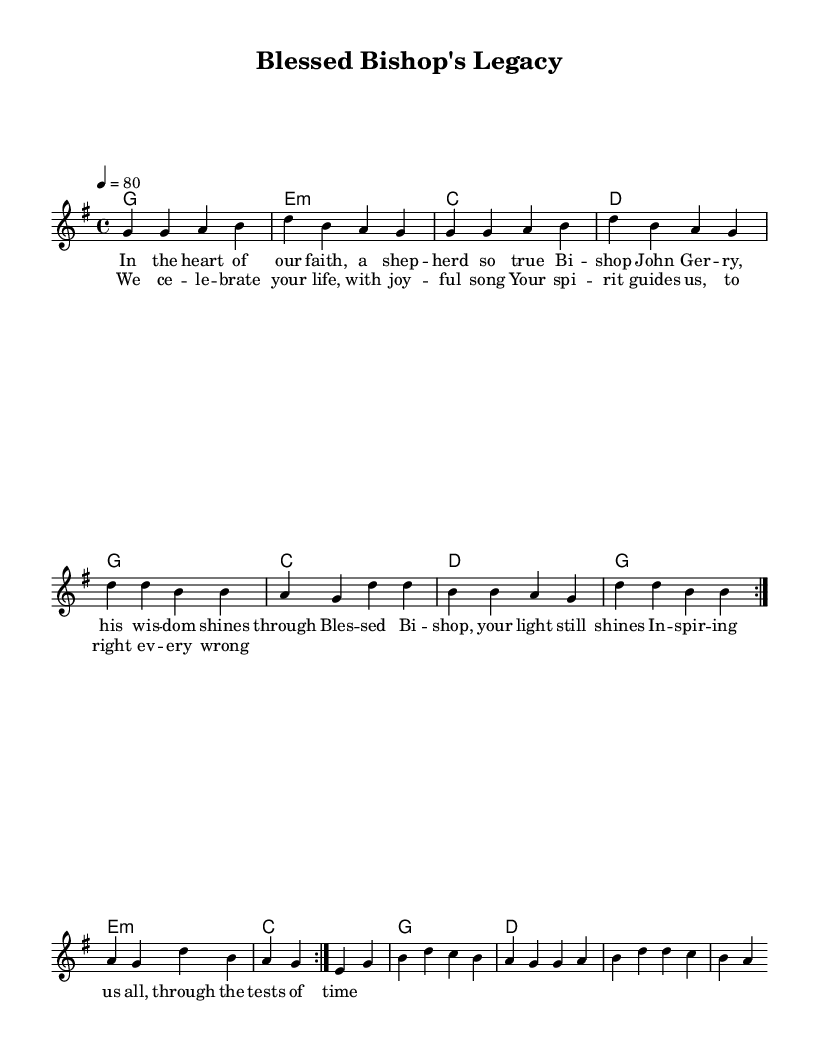What is the title of this piece? The title is found in the header section of the sheet music, clearly stating "Blessed Bishop's Legacy."
Answer: Blessed Bishop's Legacy What is the key signature of this music? The key signature is indicated at the beginning of the score, and in this case, it is G major, which has one sharp.
Answer: G major What is the time signature of this music? The time signature appears next to the key signature at the beginning of the score, showing a 4/4 pattern.
Answer: 4/4 What is the tempo marking of this piece? The tempo is provided in the global section as "4 = 80," which indicates the metronome mark and speed of the piece.
Answer: 80 How many times is the melody repeated in the first section? By looking at the repeat signs present in the melody section, it shows that the melody is repeated twice in the first section.
Answer: 2 What mood does the song aim to convey, based on the lyrics? The lyrics express joy and inspiration, indicating a celebratory and uplifting mood.
Answer: Joyful How does the bridge contribute to the overall theme of the song? The bridge reinforces the central theme by emphasizing the celebration of Bishop John Gerry’s life and guidance, linking back to the main message of inspiration.
Answer: Celebration 